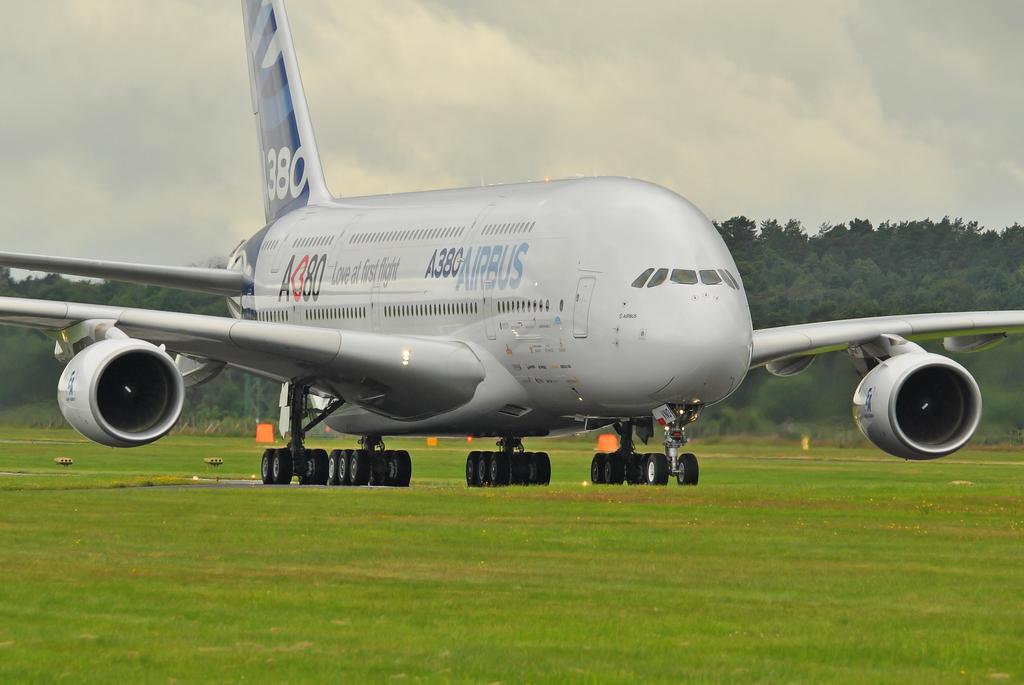Provide a one-sentence caption for the provided image. An Airbus 380 passenger jet is on the ground in a grassy area. 